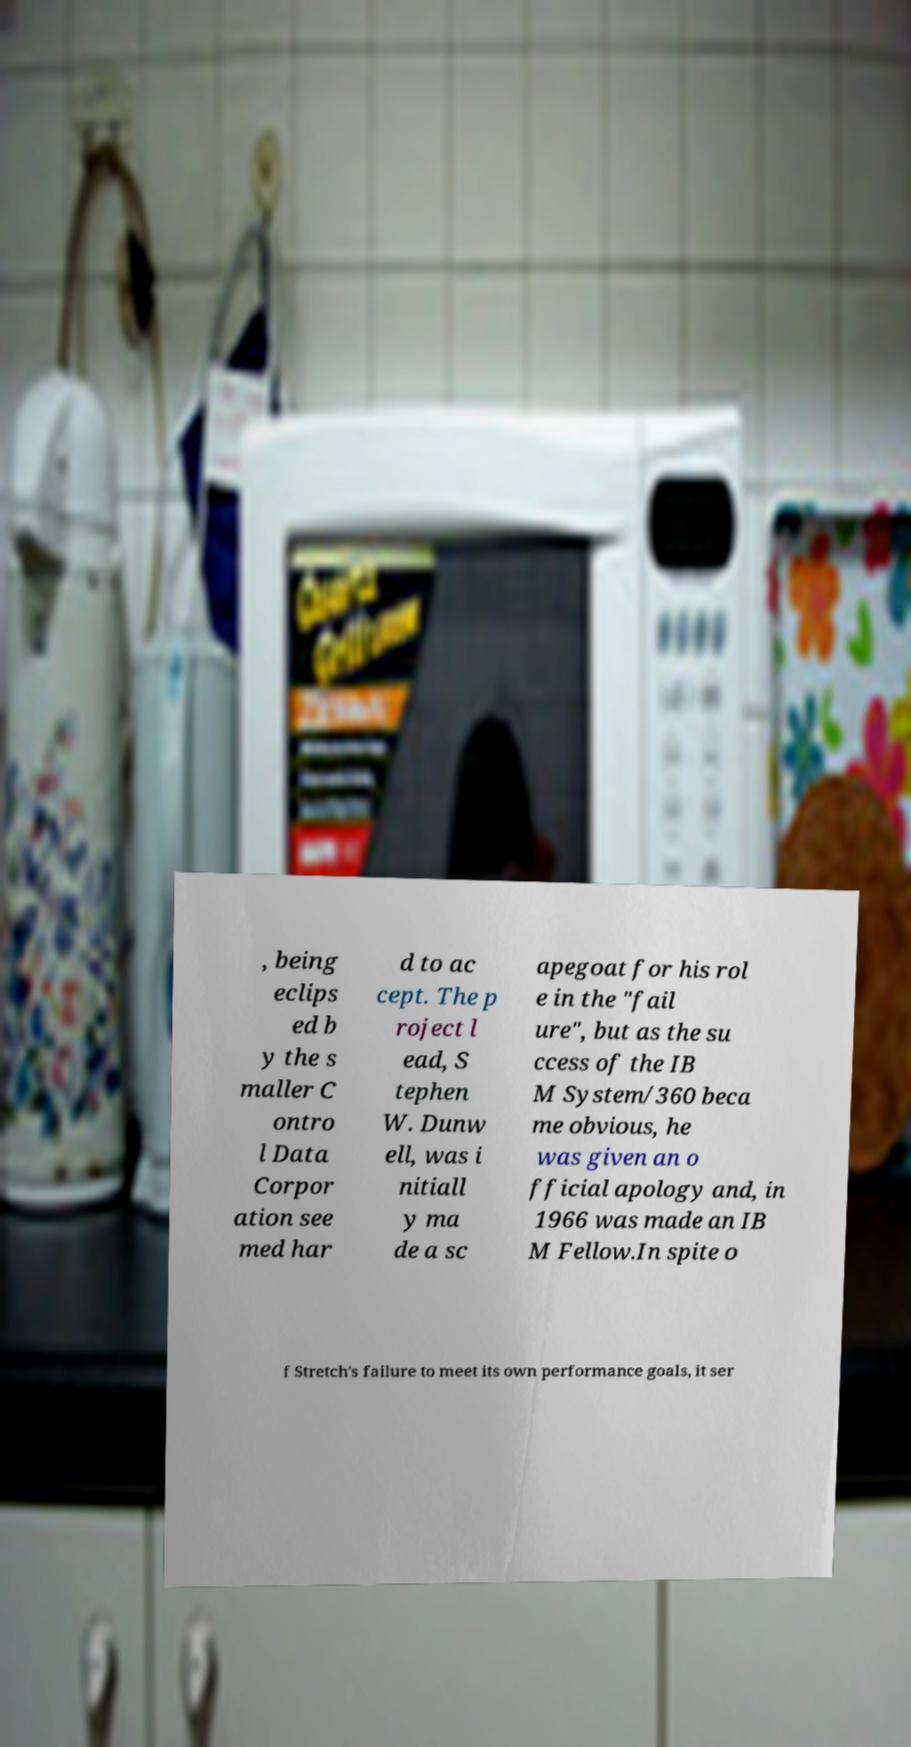What messages or text are displayed in this image? I need them in a readable, typed format. , being eclips ed b y the s maller C ontro l Data Corpor ation see med har d to ac cept. The p roject l ead, S tephen W. Dunw ell, was i nitiall y ma de a sc apegoat for his rol e in the "fail ure", but as the su ccess of the IB M System/360 beca me obvious, he was given an o fficial apology and, in 1966 was made an IB M Fellow.In spite o f Stretch's failure to meet its own performance goals, it ser 